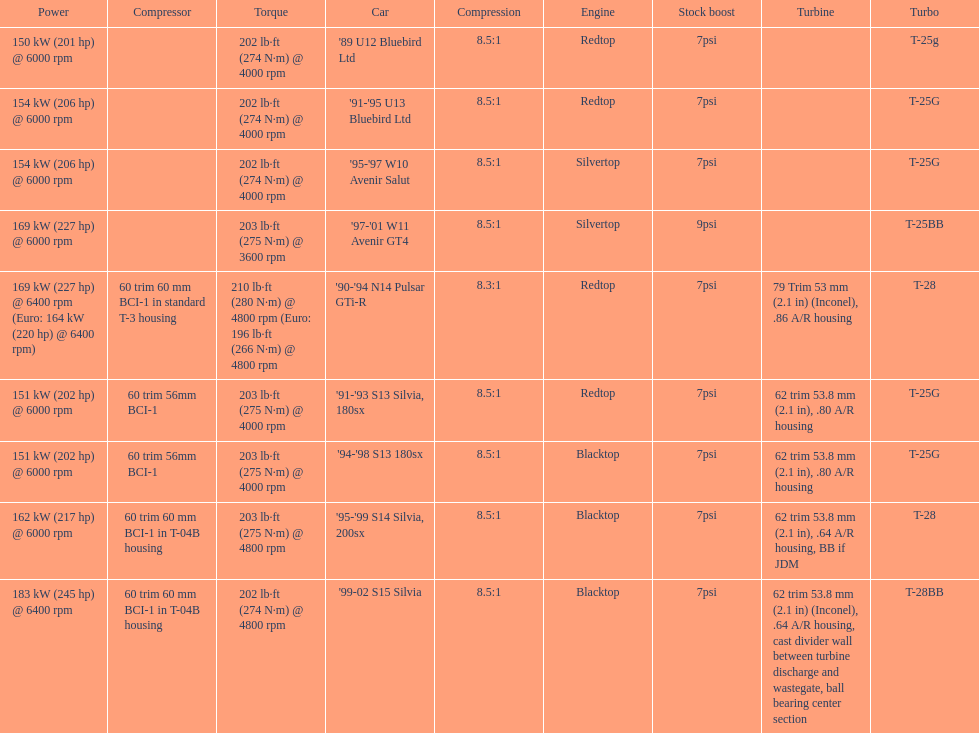Which car's power measured at higher than 6000 rpm? '90-'94 N14 Pulsar GTi-R, '99-02 S15 Silvia. Would you be able to parse every entry in this table? {'header': ['Power', 'Compressor', 'Torque', 'Car', 'Compression', 'Engine', 'Stock boost', 'Turbine', 'Turbo'], 'rows': [['150\xa0kW (201\xa0hp) @ 6000 rpm', '', '202\xa0lb·ft (274\xa0N·m) @ 4000 rpm', "'89 U12 Bluebird Ltd", '8.5:1', 'Redtop', '7psi', '', 'T-25g'], ['154\xa0kW (206\xa0hp) @ 6000 rpm', '', '202\xa0lb·ft (274\xa0N·m) @ 4000 rpm', "'91-'95 U13 Bluebird Ltd", '8.5:1', 'Redtop', '7psi', '', 'T-25G'], ['154\xa0kW (206\xa0hp) @ 6000 rpm', '', '202\xa0lb·ft (274\xa0N·m) @ 4000 rpm', "'95-'97 W10 Avenir Salut", '8.5:1', 'Silvertop', '7psi', '', 'T-25G'], ['169\xa0kW (227\xa0hp) @ 6000 rpm', '', '203\xa0lb·ft (275\xa0N·m) @ 3600 rpm', "'97-'01 W11 Avenir GT4", '8.5:1', 'Silvertop', '9psi', '', 'T-25BB'], ['169\xa0kW (227\xa0hp) @ 6400 rpm (Euro: 164\xa0kW (220\xa0hp) @ 6400 rpm)', '60 trim 60\xa0mm BCI-1 in standard T-3 housing', '210\xa0lb·ft (280\xa0N·m) @ 4800 rpm (Euro: 196\xa0lb·ft (266\xa0N·m) @ 4800 rpm', "'90-'94 N14 Pulsar GTi-R", '8.3:1', 'Redtop', '7psi', '79 Trim 53\xa0mm (2.1\xa0in) (Inconel), .86 A/R housing', 'T-28'], ['151\xa0kW (202\xa0hp) @ 6000 rpm', '60 trim 56mm BCI-1', '203\xa0lb·ft (275\xa0N·m) @ 4000 rpm', "'91-'93 S13 Silvia, 180sx", '8.5:1', 'Redtop', '7psi', '62 trim 53.8\xa0mm (2.1\xa0in), .80 A/R housing', 'T-25G'], ['151\xa0kW (202\xa0hp) @ 6000 rpm', '60 trim 56mm BCI-1', '203\xa0lb·ft (275\xa0N·m) @ 4000 rpm', "'94-'98 S13 180sx", '8.5:1', 'Blacktop', '7psi', '62 trim 53.8\xa0mm (2.1\xa0in), .80 A/R housing', 'T-25G'], ['162\xa0kW (217\xa0hp) @ 6000 rpm', '60 trim 60\xa0mm BCI-1 in T-04B housing', '203\xa0lb·ft (275\xa0N·m) @ 4800 rpm', "'95-'99 S14 Silvia, 200sx", '8.5:1', 'Blacktop', '7psi', '62 trim 53.8\xa0mm (2.1\xa0in), .64 A/R housing, BB if JDM', 'T-28'], ['183\xa0kW (245\xa0hp) @ 6400 rpm', '60 trim 60\xa0mm BCI-1 in T-04B housing', '202\xa0lb·ft (274\xa0N·m) @ 4800 rpm', "'99-02 S15 Silvia", '8.5:1', 'Blacktop', '7psi', '62 trim 53.8\xa0mm (2.1\xa0in) (Inconel), .64 A/R housing, cast divider wall between turbine discharge and wastegate, ball bearing center section', 'T-28BB']]} 